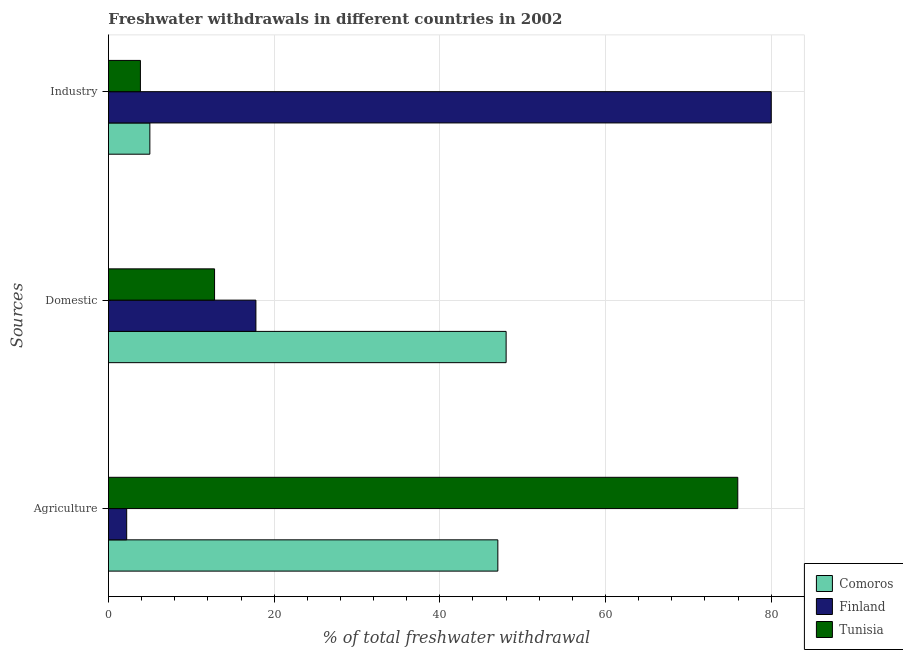How many different coloured bars are there?
Offer a terse response. 3. Are the number of bars per tick equal to the number of legend labels?
Ensure brevity in your answer.  Yes. Are the number of bars on each tick of the Y-axis equal?
Your response must be concise. Yes. How many bars are there on the 2nd tick from the top?
Make the answer very short. 3. What is the label of the 2nd group of bars from the top?
Provide a succinct answer. Domestic. What is the percentage of freshwater withdrawal for agriculture in Finland?
Your answer should be very brief. 2.2. Across all countries, what is the maximum percentage of freshwater withdrawal for domestic purposes?
Make the answer very short. 48. Across all countries, what is the minimum percentage of freshwater withdrawal for domestic purposes?
Make the answer very short. 12.81. In which country was the percentage of freshwater withdrawal for industry minimum?
Ensure brevity in your answer.  Tunisia. What is the total percentage of freshwater withdrawal for industry in the graph?
Your answer should be compact. 88.86. What is the difference between the percentage of freshwater withdrawal for agriculture in Finland and that in Comoros?
Provide a short and direct response. -44.8. What is the difference between the percentage of freshwater withdrawal for agriculture in Tunisia and the percentage of freshwater withdrawal for industry in Comoros?
Provide a succinct answer. 70.96. What is the average percentage of freshwater withdrawal for domestic purposes per country?
Your answer should be very brief. 26.2. What is the difference between the percentage of freshwater withdrawal for domestic purposes and percentage of freshwater withdrawal for agriculture in Finland?
Provide a succinct answer. 15.6. In how many countries, is the percentage of freshwater withdrawal for industry greater than 80 %?
Offer a very short reply. 0. What is the ratio of the percentage of freshwater withdrawal for agriculture in Finland to that in Comoros?
Offer a very short reply. 0.05. Is the difference between the percentage of freshwater withdrawal for domestic purposes in Finland and Tunisia greater than the difference between the percentage of freshwater withdrawal for industry in Finland and Tunisia?
Provide a succinct answer. No. What is the difference between the highest and the second highest percentage of freshwater withdrawal for agriculture?
Provide a short and direct response. 28.96. What is the difference between the highest and the lowest percentage of freshwater withdrawal for industry?
Your response must be concise. 76.14. In how many countries, is the percentage of freshwater withdrawal for domestic purposes greater than the average percentage of freshwater withdrawal for domestic purposes taken over all countries?
Your answer should be compact. 1. What does the 2nd bar from the bottom in Industry represents?
Your answer should be very brief. Finland. Is it the case that in every country, the sum of the percentage of freshwater withdrawal for agriculture and percentage of freshwater withdrawal for domestic purposes is greater than the percentage of freshwater withdrawal for industry?
Provide a short and direct response. No. How many countries are there in the graph?
Provide a short and direct response. 3. What is the difference between two consecutive major ticks on the X-axis?
Make the answer very short. 20. Are the values on the major ticks of X-axis written in scientific E-notation?
Offer a very short reply. No. Does the graph contain any zero values?
Make the answer very short. No. Does the graph contain grids?
Your answer should be compact. Yes. Where does the legend appear in the graph?
Your answer should be compact. Bottom right. How many legend labels are there?
Provide a short and direct response. 3. What is the title of the graph?
Give a very brief answer. Freshwater withdrawals in different countries in 2002. Does "High income" appear as one of the legend labels in the graph?
Give a very brief answer. No. What is the label or title of the X-axis?
Your response must be concise. % of total freshwater withdrawal. What is the label or title of the Y-axis?
Offer a terse response. Sources. What is the % of total freshwater withdrawal in Finland in Agriculture?
Offer a terse response. 2.2. What is the % of total freshwater withdrawal in Tunisia in Agriculture?
Make the answer very short. 75.96. What is the % of total freshwater withdrawal in Comoros in Domestic?
Ensure brevity in your answer.  48. What is the % of total freshwater withdrawal of Tunisia in Domestic?
Your answer should be compact. 12.81. What is the % of total freshwater withdrawal of Finland in Industry?
Your response must be concise. 80. What is the % of total freshwater withdrawal in Tunisia in Industry?
Offer a terse response. 3.86. Across all Sources, what is the maximum % of total freshwater withdrawal in Finland?
Make the answer very short. 80. Across all Sources, what is the maximum % of total freshwater withdrawal of Tunisia?
Your response must be concise. 75.96. Across all Sources, what is the minimum % of total freshwater withdrawal in Finland?
Make the answer very short. 2.2. Across all Sources, what is the minimum % of total freshwater withdrawal in Tunisia?
Ensure brevity in your answer.  3.86. What is the total % of total freshwater withdrawal in Finland in the graph?
Provide a short and direct response. 100. What is the total % of total freshwater withdrawal of Tunisia in the graph?
Your answer should be compact. 92.63. What is the difference between the % of total freshwater withdrawal in Finland in Agriculture and that in Domestic?
Your answer should be very brief. -15.6. What is the difference between the % of total freshwater withdrawal in Tunisia in Agriculture and that in Domestic?
Provide a succinct answer. 63.15. What is the difference between the % of total freshwater withdrawal in Finland in Agriculture and that in Industry?
Offer a very short reply. -77.8. What is the difference between the % of total freshwater withdrawal of Tunisia in Agriculture and that in Industry?
Offer a terse response. 72.1. What is the difference between the % of total freshwater withdrawal of Comoros in Domestic and that in Industry?
Provide a short and direct response. 43. What is the difference between the % of total freshwater withdrawal in Finland in Domestic and that in Industry?
Your response must be concise. -62.2. What is the difference between the % of total freshwater withdrawal in Tunisia in Domestic and that in Industry?
Give a very brief answer. 8.95. What is the difference between the % of total freshwater withdrawal of Comoros in Agriculture and the % of total freshwater withdrawal of Finland in Domestic?
Make the answer very short. 29.2. What is the difference between the % of total freshwater withdrawal in Comoros in Agriculture and the % of total freshwater withdrawal in Tunisia in Domestic?
Ensure brevity in your answer.  34.19. What is the difference between the % of total freshwater withdrawal of Finland in Agriculture and the % of total freshwater withdrawal of Tunisia in Domestic?
Make the answer very short. -10.61. What is the difference between the % of total freshwater withdrawal of Comoros in Agriculture and the % of total freshwater withdrawal of Finland in Industry?
Your response must be concise. -33. What is the difference between the % of total freshwater withdrawal in Comoros in Agriculture and the % of total freshwater withdrawal in Tunisia in Industry?
Keep it short and to the point. 43.14. What is the difference between the % of total freshwater withdrawal of Finland in Agriculture and the % of total freshwater withdrawal of Tunisia in Industry?
Your answer should be very brief. -1.66. What is the difference between the % of total freshwater withdrawal in Comoros in Domestic and the % of total freshwater withdrawal in Finland in Industry?
Provide a short and direct response. -32. What is the difference between the % of total freshwater withdrawal of Comoros in Domestic and the % of total freshwater withdrawal of Tunisia in Industry?
Your response must be concise. 44.14. What is the difference between the % of total freshwater withdrawal in Finland in Domestic and the % of total freshwater withdrawal in Tunisia in Industry?
Your answer should be very brief. 13.94. What is the average % of total freshwater withdrawal of Comoros per Sources?
Offer a terse response. 33.33. What is the average % of total freshwater withdrawal of Finland per Sources?
Ensure brevity in your answer.  33.33. What is the average % of total freshwater withdrawal in Tunisia per Sources?
Keep it short and to the point. 30.88. What is the difference between the % of total freshwater withdrawal in Comoros and % of total freshwater withdrawal in Finland in Agriculture?
Offer a terse response. 44.8. What is the difference between the % of total freshwater withdrawal in Comoros and % of total freshwater withdrawal in Tunisia in Agriculture?
Give a very brief answer. -28.96. What is the difference between the % of total freshwater withdrawal in Finland and % of total freshwater withdrawal in Tunisia in Agriculture?
Keep it short and to the point. -73.76. What is the difference between the % of total freshwater withdrawal of Comoros and % of total freshwater withdrawal of Finland in Domestic?
Your answer should be compact. 30.2. What is the difference between the % of total freshwater withdrawal in Comoros and % of total freshwater withdrawal in Tunisia in Domestic?
Make the answer very short. 35.19. What is the difference between the % of total freshwater withdrawal of Finland and % of total freshwater withdrawal of Tunisia in Domestic?
Provide a succinct answer. 4.99. What is the difference between the % of total freshwater withdrawal of Comoros and % of total freshwater withdrawal of Finland in Industry?
Keep it short and to the point. -75. What is the difference between the % of total freshwater withdrawal of Comoros and % of total freshwater withdrawal of Tunisia in Industry?
Your response must be concise. 1.14. What is the difference between the % of total freshwater withdrawal of Finland and % of total freshwater withdrawal of Tunisia in Industry?
Give a very brief answer. 76.14. What is the ratio of the % of total freshwater withdrawal in Comoros in Agriculture to that in Domestic?
Provide a short and direct response. 0.98. What is the ratio of the % of total freshwater withdrawal of Finland in Agriculture to that in Domestic?
Give a very brief answer. 0.12. What is the ratio of the % of total freshwater withdrawal in Tunisia in Agriculture to that in Domestic?
Your answer should be very brief. 5.93. What is the ratio of the % of total freshwater withdrawal of Finland in Agriculture to that in Industry?
Offer a very short reply. 0.03. What is the ratio of the % of total freshwater withdrawal in Tunisia in Agriculture to that in Industry?
Ensure brevity in your answer.  19.68. What is the ratio of the % of total freshwater withdrawal of Finland in Domestic to that in Industry?
Make the answer very short. 0.22. What is the ratio of the % of total freshwater withdrawal of Tunisia in Domestic to that in Industry?
Give a very brief answer. 3.32. What is the difference between the highest and the second highest % of total freshwater withdrawal of Comoros?
Ensure brevity in your answer.  1. What is the difference between the highest and the second highest % of total freshwater withdrawal of Finland?
Ensure brevity in your answer.  62.2. What is the difference between the highest and the second highest % of total freshwater withdrawal in Tunisia?
Offer a very short reply. 63.15. What is the difference between the highest and the lowest % of total freshwater withdrawal of Finland?
Give a very brief answer. 77.8. What is the difference between the highest and the lowest % of total freshwater withdrawal of Tunisia?
Offer a terse response. 72.1. 